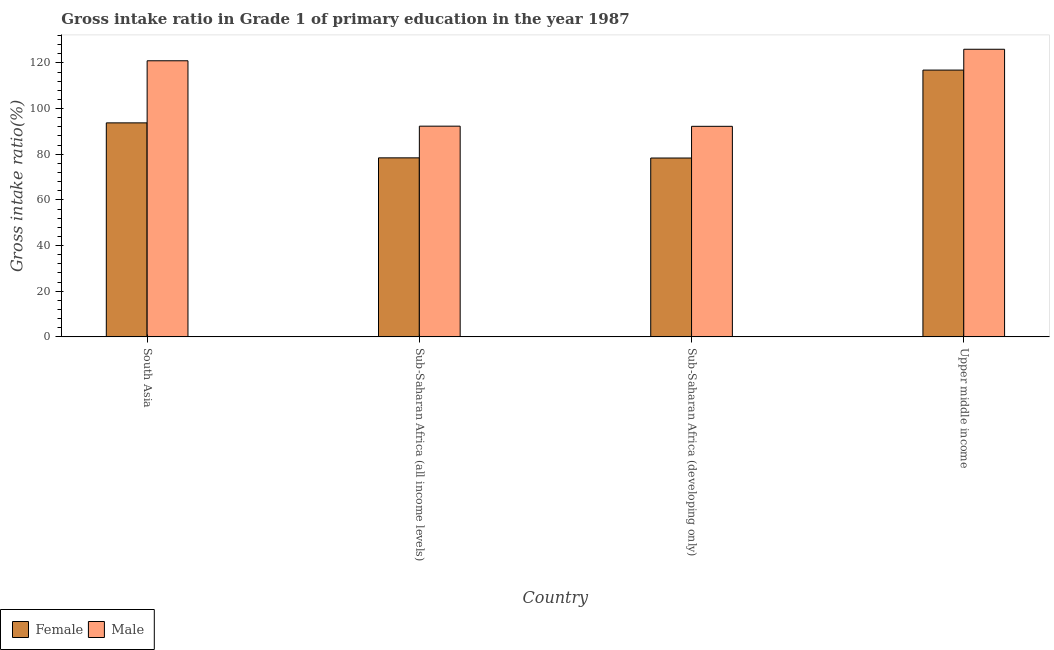How many different coloured bars are there?
Provide a short and direct response. 2. How many groups of bars are there?
Your response must be concise. 4. Are the number of bars per tick equal to the number of legend labels?
Provide a succinct answer. Yes. What is the label of the 4th group of bars from the left?
Your response must be concise. Upper middle income. What is the gross intake ratio(male) in Sub-Saharan Africa (all income levels)?
Your answer should be very brief. 92.29. Across all countries, what is the maximum gross intake ratio(female)?
Ensure brevity in your answer.  116.85. Across all countries, what is the minimum gross intake ratio(male)?
Your answer should be very brief. 92.22. In which country was the gross intake ratio(male) maximum?
Give a very brief answer. Upper middle income. In which country was the gross intake ratio(male) minimum?
Give a very brief answer. Sub-Saharan Africa (developing only). What is the total gross intake ratio(male) in the graph?
Provide a succinct answer. 431.41. What is the difference between the gross intake ratio(male) in South Asia and that in Sub-Saharan Africa (developing only)?
Keep it short and to the point. 28.71. What is the difference between the gross intake ratio(female) in Sub-Saharan Africa (all income levels) and the gross intake ratio(male) in Upper middle income?
Provide a succinct answer. -47.57. What is the average gross intake ratio(male) per country?
Your answer should be very brief. 107.85. What is the difference between the gross intake ratio(male) and gross intake ratio(female) in South Asia?
Offer a very short reply. 27.2. What is the ratio of the gross intake ratio(female) in Sub-Saharan Africa (all income levels) to that in Sub-Saharan Africa (developing only)?
Your response must be concise. 1. Is the gross intake ratio(female) in South Asia less than that in Sub-Saharan Africa (all income levels)?
Provide a succinct answer. No. What is the difference between the highest and the second highest gross intake ratio(male)?
Your response must be concise. 5.04. What is the difference between the highest and the lowest gross intake ratio(female)?
Your answer should be very brief. 38.51. What does the 1st bar from the right in Sub-Saharan Africa (all income levels) represents?
Your answer should be very brief. Male. How many bars are there?
Ensure brevity in your answer.  8. How many countries are there in the graph?
Make the answer very short. 4. Does the graph contain any zero values?
Provide a short and direct response. No. Where does the legend appear in the graph?
Provide a short and direct response. Bottom left. How are the legend labels stacked?
Your response must be concise. Horizontal. What is the title of the graph?
Your response must be concise. Gross intake ratio in Grade 1 of primary education in the year 1987. What is the label or title of the X-axis?
Provide a short and direct response. Country. What is the label or title of the Y-axis?
Your answer should be very brief. Gross intake ratio(%). What is the Gross intake ratio(%) in Female in South Asia?
Give a very brief answer. 93.73. What is the Gross intake ratio(%) in Male in South Asia?
Give a very brief answer. 120.93. What is the Gross intake ratio(%) in Female in Sub-Saharan Africa (all income levels)?
Your response must be concise. 78.41. What is the Gross intake ratio(%) of Male in Sub-Saharan Africa (all income levels)?
Ensure brevity in your answer.  92.29. What is the Gross intake ratio(%) of Female in Sub-Saharan Africa (developing only)?
Keep it short and to the point. 78.33. What is the Gross intake ratio(%) of Male in Sub-Saharan Africa (developing only)?
Your answer should be compact. 92.22. What is the Gross intake ratio(%) in Female in Upper middle income?
Ensure brevity in your answer.  116.85. What is the Gross intake ratio(%) of Male in Upper middle income?
Make the answer very short. 125.97. Across all countries, what is the maximum Gross intake ratio(%) in Female?
Give a very brief answer. 116.85. Across all countries, what is the maximum Gross intake ratio(%) in Male?
Provide a short and direct response. 125.97. Across all countries, what is the minimum Gross intake ratio(%) of Female?
Offer a very short reply. 78.33. Across all countries, what is the minimum Gross intake ratio(%) in Male?
Your response must be concise. 92.22. What is the total Gross intake ratio(%) in Female in the graph?
Offer a very short reply. 367.32. What is the total Gross intake ratio(%) in Male in the graph?
Keep it short and to the point. 431.41. What is the difference between the Gross intake ratio(%) in Female in South Asia and that in Sub-Saharan Africa (all income levels)?
Offer a terse response. 15.32. What is the difference between the Gross intake ratio(%) of Male in South Asia and that in Sub-Saharan Africa (all income levels)?
Make the answer very short. 28.64. What is the difference between the Gross intake ratio(%) in Female in South Asia and that in Sub-Saharan Africa (developing only)?
Provide a short and direct response. 15.4. What is the difference between the Gross intake ratio(%) in Male in South Asia and that in Sub-Saharan Africa (developing only)?
Offer a terse response. 28.71. What is the difference between the Gross intake ratio(%) in Female in South Asia and that in Upper middle income?
Make the answer very short. -23.12. What is the difference between the Gross intake ratio(%) of Male in South Asia and that in Upper middle income?
Provide a short and direct response. -5.04. What is the difference between the Gross intake ratio(%) of Female in Sub-Saharan Africa (all income levels) and that in Sub-Saharan Africa (developing only)?
Your response must be concise. 0.07. What is the difference between the Gross intake ratio(%) of Male in Sub-Saharan Africa (all income levels) and that in Sub-Saharan Africa (developing only)?
Offer a very short reply. 0.07. What is the difference between the Gross intake ratio(%) of Female in Sub-Saharan Africa (all income levels) and that in Upper middle income?
Keep it short and to the point. -38.44. What is the difference between the Gross intake ratio(%) in Male in Sub-Saharan Africa (all income levels) and that in Upper middle income?
Provide a succinct answer. -33.69. What is the difference between the Gross intake ratio(%) in Female in Sub-Saharan Africa (developing only) and that in Upper middle income?
Your answer should be very brief. -38.51. What is the difference between the Gross intake ratio(%) of Male in Sub-Saharan Africa (developing only) and that in Upper middle income?
Offer a terse response. -33.75. What is the difference between the Gross intake ratio(%) in Female in South Asia and the Gross intake ratio(%) in Male in Sub-Saharan Africa (all income levels)?
Offer a terse response. 1.44. What is the difference between the Gross intake ratio(%) in Female in South Asia and the Gross intake ratio(%) in Male in Sub-Saharan Africa (developing only)?
Provide a short and direct response. 1.51. What is the difference between the Gross intake ratio(%) of Female in South Asia and the Gross intake ratio(%) of Male in Upper middle income?
Your response must be concise. -32.24. What is the difference between the Gross intake ratio(%) of Female in Sub-Saharan Africa (all income levels) and the Gross intake ratio(%) of Male in Sub-Saharan Africa (developing only)?
Provide a succinct answer. -13.81. What is the difference between the Gross intake ratio(%) in Female in Sub-Saharan Africa (all income levels) and the Gross intake ratio(%) in Male in Upper middle income?
Make the answer very short. -47.57. What is the difference between the Gross intake ratio(%) in Female in Sub-Saharan Africa (developing only) and the Gross intake ratio(%) in Male in Upper middle income?
Your response must be concise. -47.64. What is the average Gross intake ratio(%) in Female per country?
Make the answer very short. 91.83. What is the average Gross intake ratio(%) of Male per country?
Give a very brief answer. 107.85. What is the difference between the Gross intake ratio(%) of Female and Gross intake ratio(%) of Male in South Asia?
Offer a very short reply. -27.2. What is the difference between the Gross intake ratio(%) of Female and Gross intake ratio(%) of Male in Sub-Saharan Africa (all income levels)?
Your response must be concise. -13.88. What is the difference between the Gross intake ratio(%) of Female and Gross intake ratio(%) of Male in Sub-Saharan Africa (developing only)?
Your response must be concise. -13.88. What is the difference between the Gross intake ratio(%) of Female and Gross intake ratio(%) of Male in Upper middle income?
Give a very brief answer. -9.13. What is the ratio of the Gross intake ratio(%) in Female in South Asia to that in Sub-Saharan Africa (all income levels)?
Ensure brevity in your answer.  1.2. What is the ratio of the Gross intake ratio(%) in Male in South Asia to that in Sub-Saharan Africa (all income levels)?
Make the answer very short. 1.31. What is the ratio of the Gross intake ratio(%) of Female in South Asia to that in Sub-Saharan Africa (developing only)?
Provide a short and direct response. 1.2. What is the ratio of the Gross intake ratio(%) in Male in South Asia to that in Sub-Saharan Africa (developing only)?
Offer a terse response. 1.31. What is the ratio of the Gross intake ratio(%) in Female in South Asia to that in Upper middle income?
Provide a succinct answer. 0.8. What is the ratio of the Gross intake ratio(%) in Female in Sub-Saharan Africa (all income levels) to that in Sub-Saharan Africa (developing only)?
Your answer should be compact. 1. What is the ratio of the Gross intake ratio(%) in Female in Sub-Saharan Africa (all income levels) to that in Upper middle income?
Offer a very short reply. 0.67. What is the ratio of the Gross intake ratio(%) of Male in Sub-Saharan Africa (all income levels) to that in Upper middle income?
Provide a short and direct response. 0.73. What is the ratio of the Gross intake ratio(%) in Female in Sub-Saharan Africa (developing only) to that in Upper middle income?
Your answer should be very brief. 0.67. What is the ratio of the Gross intake ratio(%) of Male in Sub-Saharan Africa (developing only) to that in Upper middle income?
Provide a succinct answer. 0.73. What is the difference between the highest and the second highest Gross intake ratio(%) of Female?
Your answer should be compact. 23.12. What is the difference between the highest and the second highest Gross intake ratio(%) in Male?
Keep it short and to the point. 5.04. What is the difference between the highest and the lowest Gross intake ratio(%) of Female?
Your answer should be very brief. 38.51. What is the difference between the highest and the lowest Gross intake ratio(%) in Male?
Ensure brevity in your answer.  33.75. 